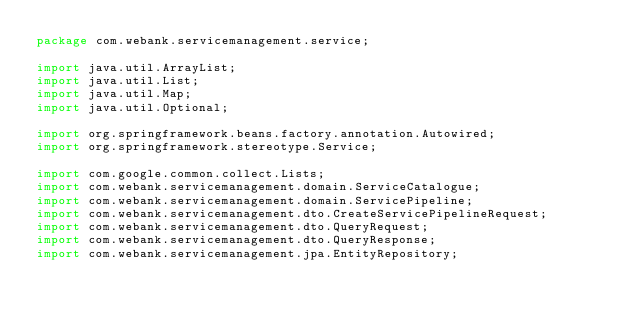Convert code to text. <code><loc_0><loc_0><loc_500><loc_500><_Java_>package com.webank.servicemanagement.service;

import java.util.ArrayList;
import java.util.List;
import java.util.Map;
import java.util.Optional;

import org.springframework.beans.factory.annotation.Autowired;
import org.springframework.stereotype.Service;

import com.google.common.collect.Lists;
import com.webank.servicemanagement.domain.ServiceCatalogue;
import com.webank.servicemanagement.domain.ServicePipeline;
import com.webank.servicemanagement.dto.CreateServicePipelineRequest;
import com.webank.servicemanagement.dto.QueryRequest;
import com.webank.servicemanagement.dto.QueryResponse;
import com.webank.servicemanagement.jpa.EntityRepository;</code> 